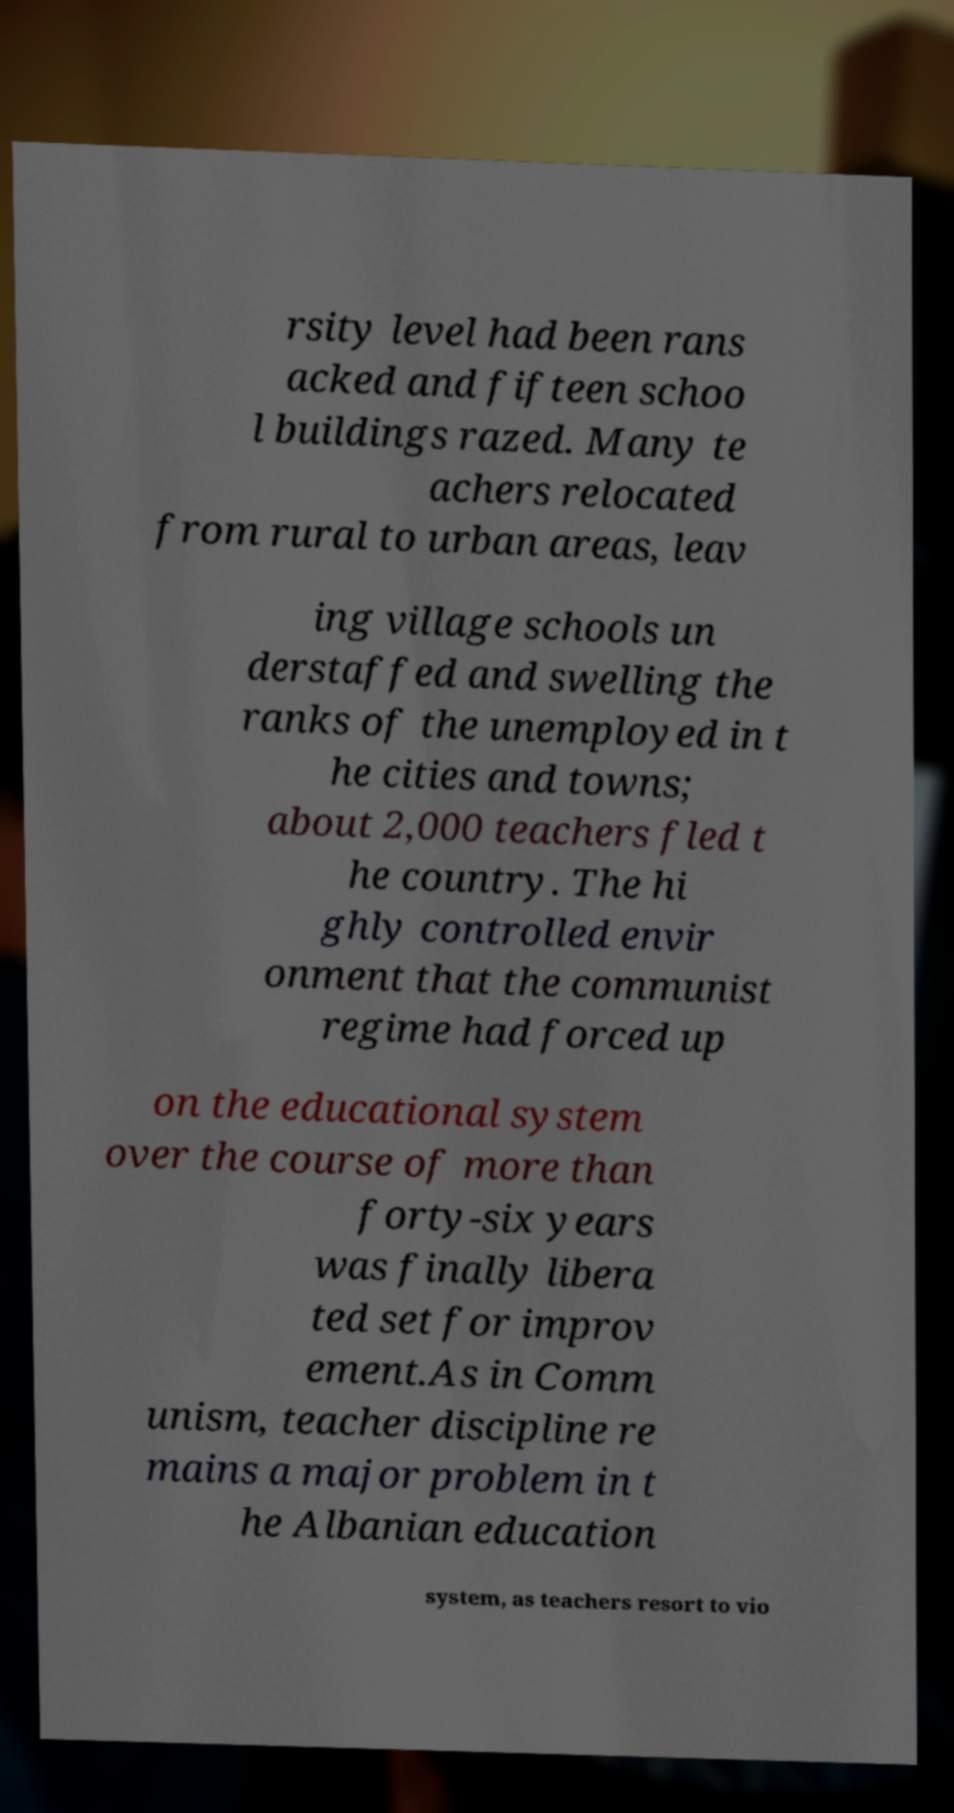Could you assist in decoding the text presented in this image and type it out clearly? rsity level had been rans acked and fifteen schoo l buildings razed. Many te achers relocated from rural to urban areas, leav ing village schools un derstaffed and swelling the ranks of the unemployed in t he cities and towns; about 2,000 teachers fled t he country. The hi ghly controlled envir onment that the communist regime had forced up on the educational system over the course of more than forty-six years was finally libera ted set for improv ement.As in Comm unism, teacher discipline re mains a major problem in t he Albanian education system, as teachers resort to vio 